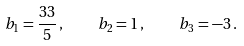Convert formula to latex. <formula><loc_0><loc_0><loc_500><loc_500>b _ { 1 } = \frac { 3 3 } { 5 } \, , \quad b _ { 2 } = 1 \, , \quad b _ { 3 } = - 3 \, .</formula> 